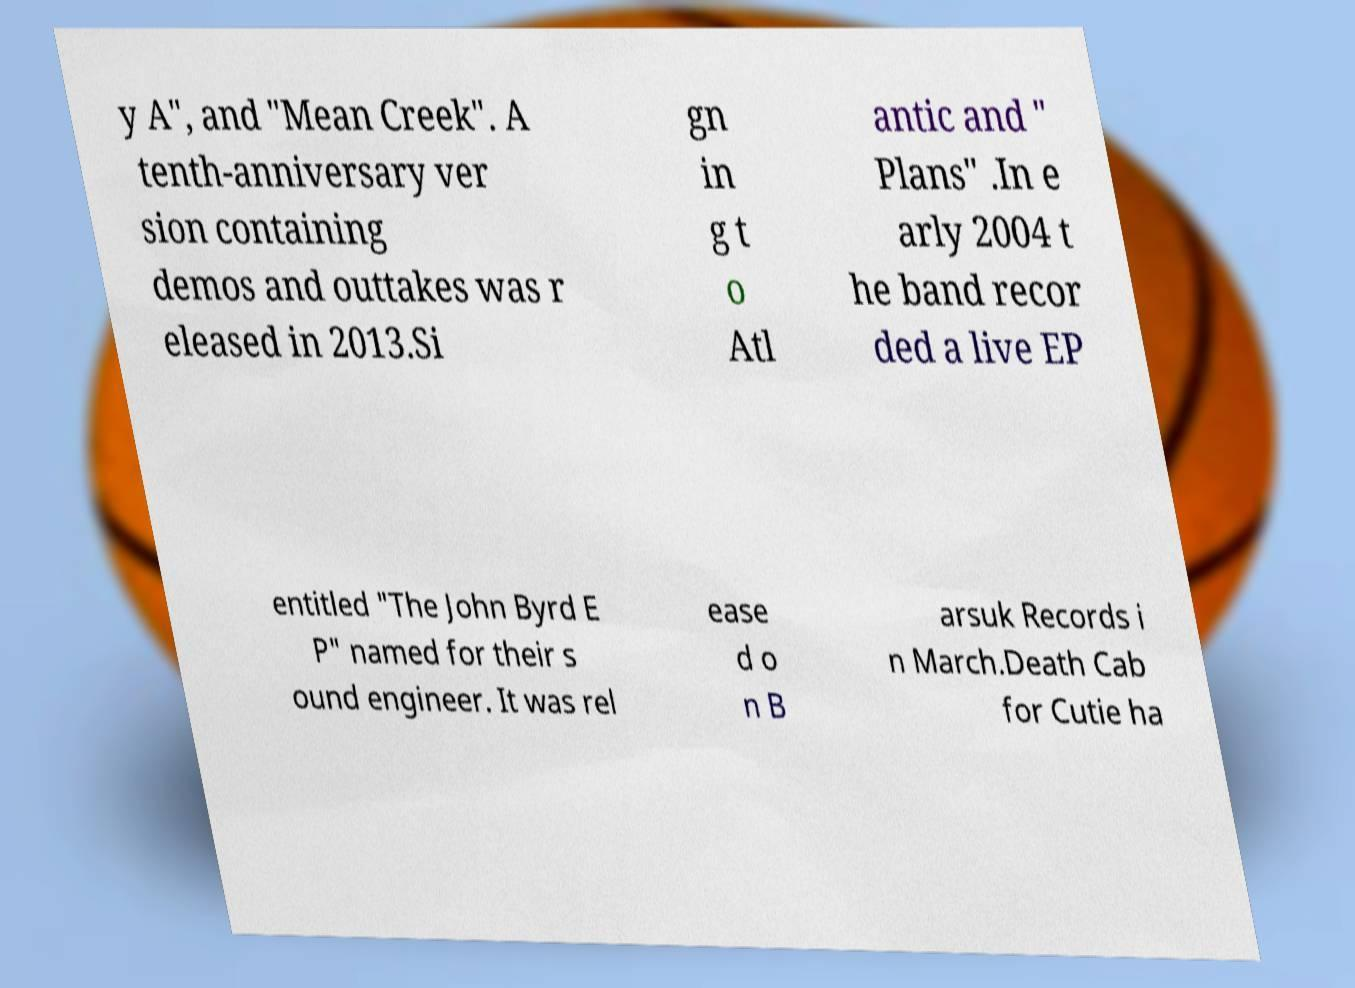I need the written content from this picture converted into text. Can you do that? y A", and "Mean Creek". A tenth-anniversary ver sion containing demos and outtakes was r eleased in 2013.Si gn in g t o Atl antic and " Plans" .In e arly 2004 t he band recor ded a live EP entitled "The John Byrd E P" named for their s ound engineer. It was rel ease d o n B arsuk Records i n March.Death Cab for Cutie ha 